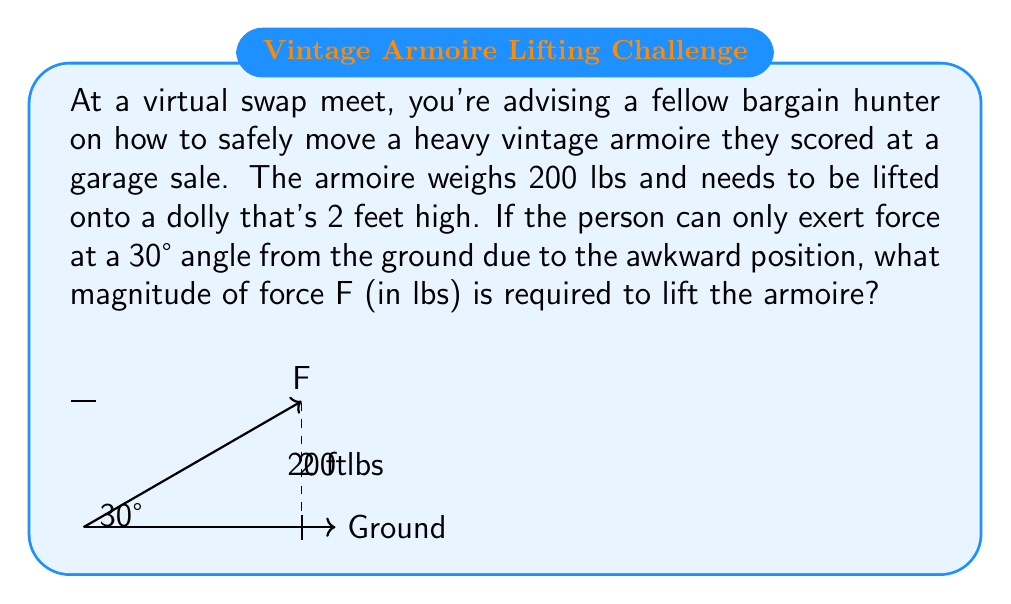Show me your answer to this math problem. Let's approach this step-by-step using vector resolution:

1) The force F applied at a 30° angle can be resolved into vertical and horizontal components:
   $$F_y = F \sin(30°)$$
   $$F_x = F \cos(30°)$$

2) We're only concerned with the vertical component $F_y$ as it's what lifts the armoire against gravity.

3) For the armoire to be lifted, the vertical component must equal the weight of the armoire:
   $$F_y = 200 \text{ lbs}$$

4) Substituting this into the equation from step 1:
   $$200 = F \sin(30°)$$

5) We know that $\sin(30°) = 0.5$, so:
   $$200 = F(0.5)$$

6) Solving for F:
   $$F = \frac{200}{0.5} = 400 \text{ lbs}$$

Therefore, a force of 400 lbs applied at a 30° angle is required to lift the armoire.
Answer: 400 lbs 